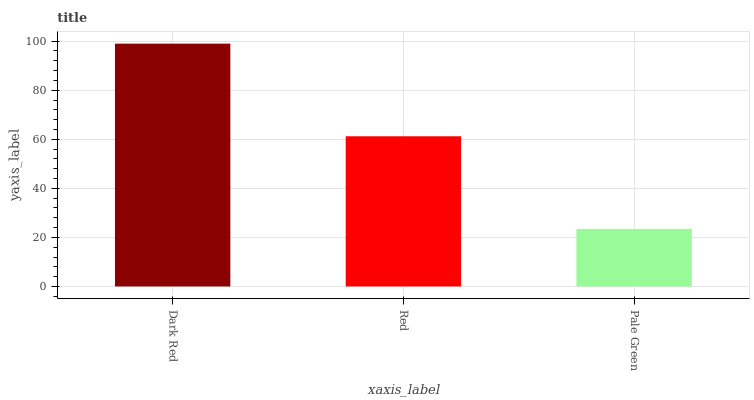Is Pale Green the minimum?
Answer yes or no. Yes. Is Dark Red the maximum?
Answer yes or no. Yes. Is Red the minimum?
Answer yes or no. No. Is Red the maximum?
Answer yes or no. No. Is Dark Red greater than Red?
Answer yes or no. Yes. Is Red less than Dark Red?
Answer yes or no. Yes. Is Red greater than Dark Red?
Answer yes or no. No. Is Dark Red less than Red?
Answer yes or no. No. Is Red the high median?
Answer yes or no. Yes. Is Red the low median?
Answer yes or no. Yes. Is Pale Green the high median?
Answer yes or no. No. Is Pale Green the low median?
Answer yes or no. No. 